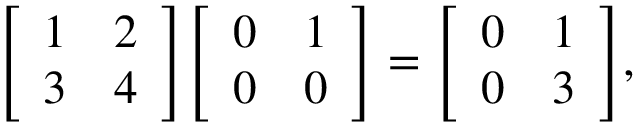Convert formula to latex. <formula><loc_0><loc_0><loc_500><loc_500>{ \left [ \begin{array} { l l } { 1 } & { 2 } \\ { 3 } & { 4 } \end{array} \right ] } { \left [ \begin{array} { l l } { 0 } & { 1 } \\ { 0 } & { 0 } \end{array} \right ] } = { \left [ \begin{array} { l l } { 0 } & { 1 } \\ { 0 } & { 3 } \end{array} \right ] } ,</formula> 